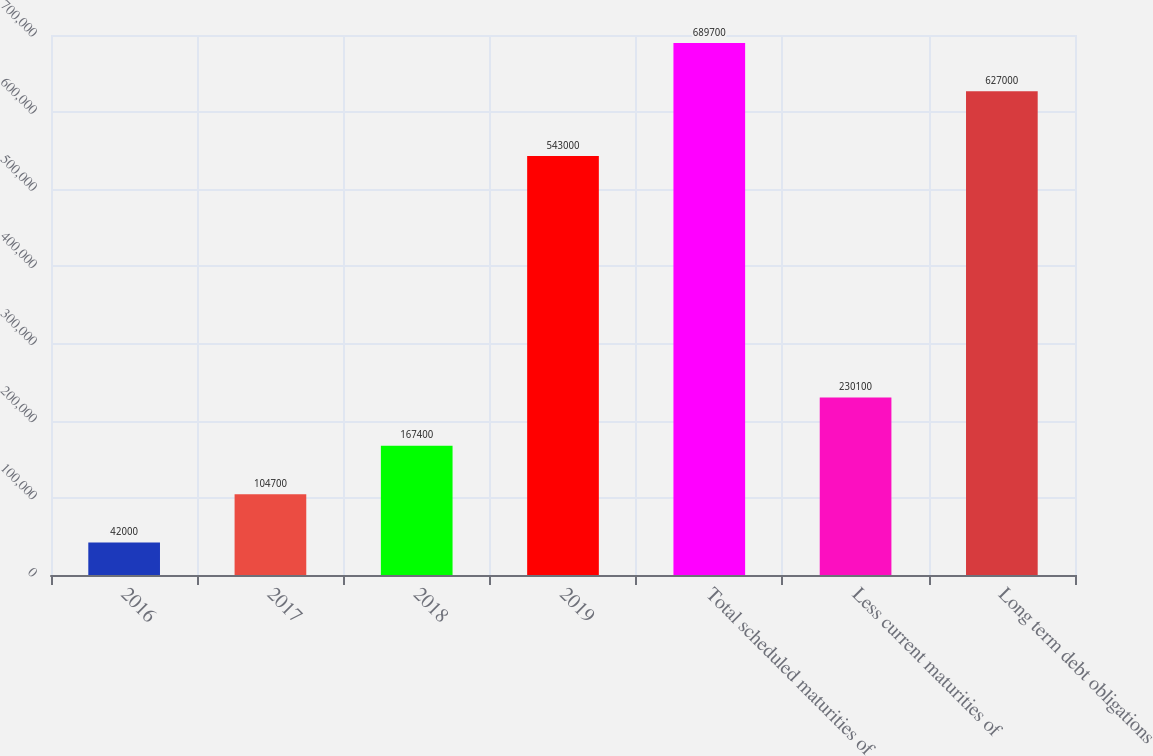Convert chart to OTSL. <chart><loc_0><loc_0><loc_500><loc_500><bar_chart><fcel>2016<fcel>2017<fcel>2018<fcel>2019<fcel>Total scheduled maturities of<fcel>Less current maturities of<fcel>Long term debt obligations<nl><fcel>42000<fcel>104700<fcel>167400<fcel>543000<fcel>689700<fcel>230100<fcel>627000<nl></chart> 